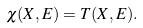<formula> <loc_0><loc_0><loc_500><loc_500>\chi ( X , E ) = T ( X , E ) .</formula> 